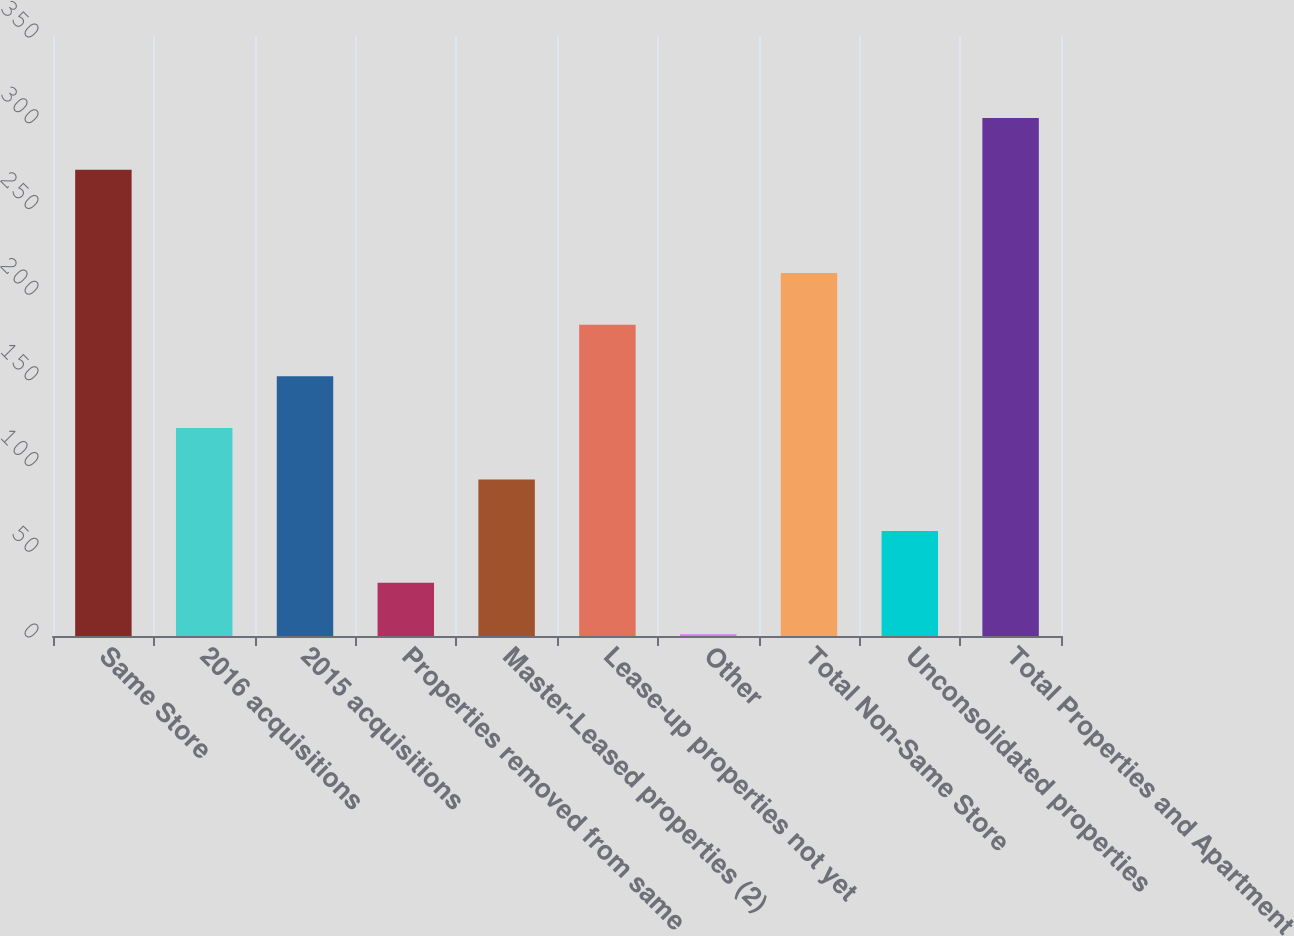Convert chart. <chart><loc_0><loc_0><loc_500><loc_500><bar_chart><fcel>Same Store<fcel>2016 acquisitions<fcel>2015 acquisitions<fcel>Properties removed from same<fcel>Master-Leased properties (2)<fcel>Lease-up properties not yet<fcel>Other<fcel>Total Non-Same Store<fcel>Unconsolidated properties<fcel>Total Properties and Apartment<nl><fcel>272<fcel>121.4<fcel>151.5<fcel>31.1<fcel>91.3<fcel>181.6<fcel>1<fcel>211.7<fcel>61.2<fcel>302.1<nl></chart> 